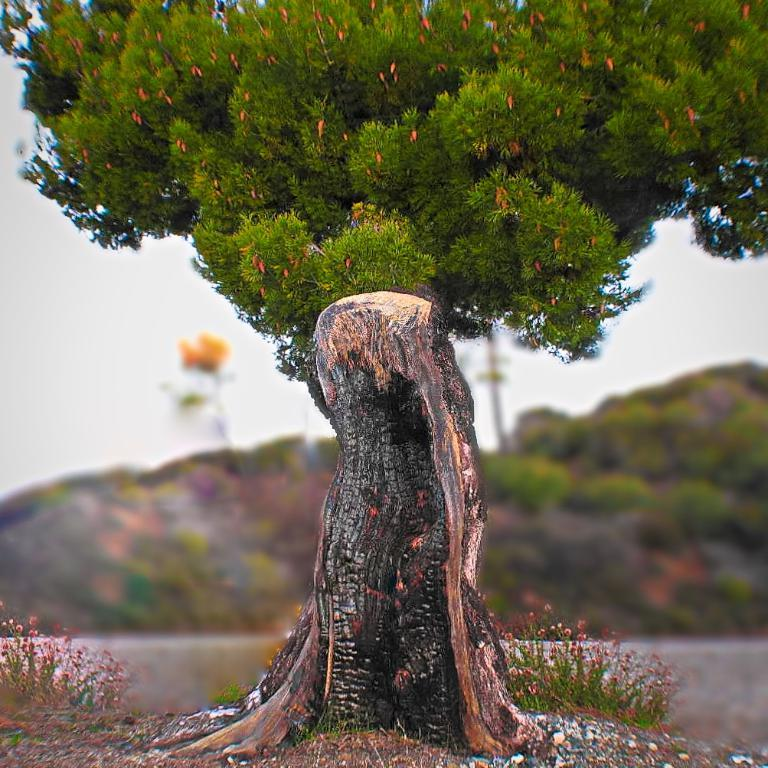What type of natural element can be seen in the image? There is a tree in the image. What object is present near the tree? There is a trunk in the image. What geographical feature is visible in the background of the image? There is a mountain visible in the background of the image. How is the mountain depicted in the image? The mountain appears to be blurred. What type of kitten is being taught to use the lift in the image? There is no kitten or lift present in the image. What subject is being taught in the image? The image does not depict any teaching or learning activity. 